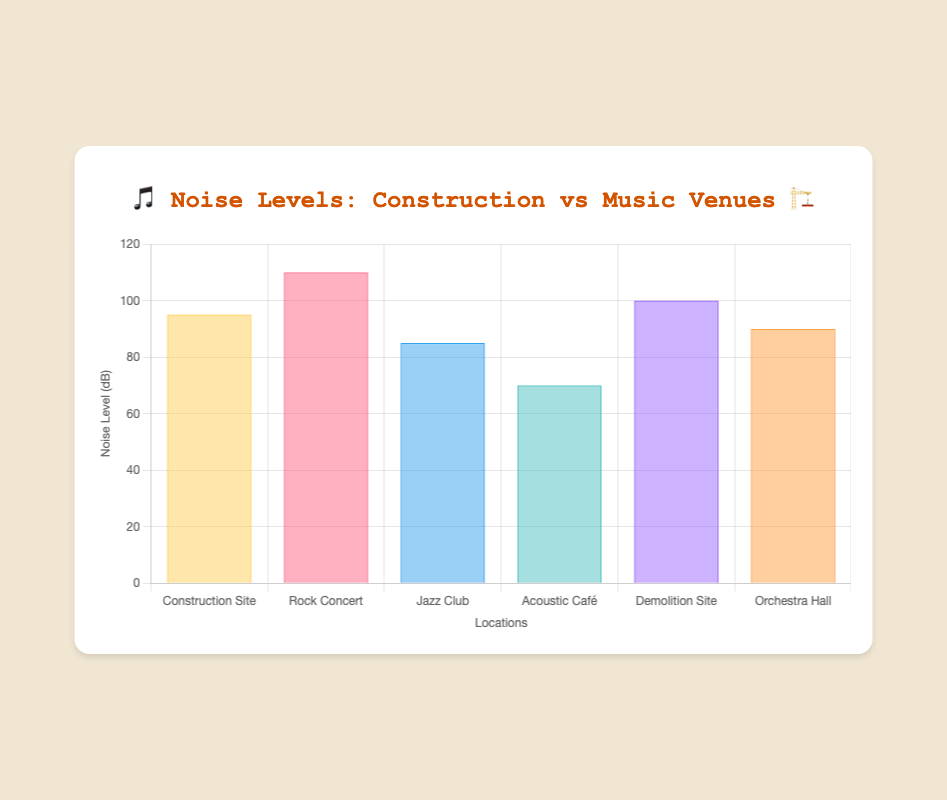Which location has the highest noise level? The location with the highest noise level can be identified by looking at the bar with the greatest height on the chart. In this case, the "Rock Concert" bar is the tallest.
Answer: Rock Concert 🎸 Which location is quieter, the Orchestra Hall or the Jazz Club? Compare the heights of the bars representing "Orchestra Hall" and "Jazz Club". The "Jazz Club" bar is shorter than the "Orchestra Hall" bar, indicating a lower noise level.
Answer: Jazz Club 🎷 What are the noise levels of the Construction Site and Demolition Site, and which is louder? The noise levels can be read directly from the chart. "Construction Site" has a noise level of 95 dB. "Demolition Site" has a noise level of 100 dB. Comparing these, "Demolition Site" is louder.
Answer: Demolition Site 🔨 How much louder is the Rock Concert compared to the Acoustic Café? Find the noise levels for both locations: "Rock Concert" is 110 dB, and "Acoustic Café" is 70 dB. Subtract the noise level of the Acoustic Café from the Rock Concert: 110 - 70 = 40 dB.
Answer: 40 dB Which locations have noise levels below 90 dB? Identify the bars that are below the 90 dB mark. "Jazz Club" (85 dB) and "Acoustic Café" (70 dB) both have noise levels below 90 dB.
Answer: Jazz Club 🎷 and Acoustic Café 🎵 What is the average noise level across all locations? Add up all the noise levels: 95 + 110 + 85 + 70 + 100 + 90 = 550. There are 6 locations, so divide the total by 6: 550 / 6 ≈ 91.67 dB.
Answer: 91.67 dB Is the noise level at the Construction Site greater than or equal to that of the Orchestra Hall? Compare the noise levels: "Construction Site" is 95 dB, while "Orchestra Hall" is 90 dB. Since 95 is greater than 90, the answer is yes.
Answer: Yes Which location's noise level is closest to 80 dB? Check all the noise levels and find the one closest to 80 dB. "Jazz Club" has a noise level of 85 dB, which is the nearest.
Answer: Jazz Club 🎷 